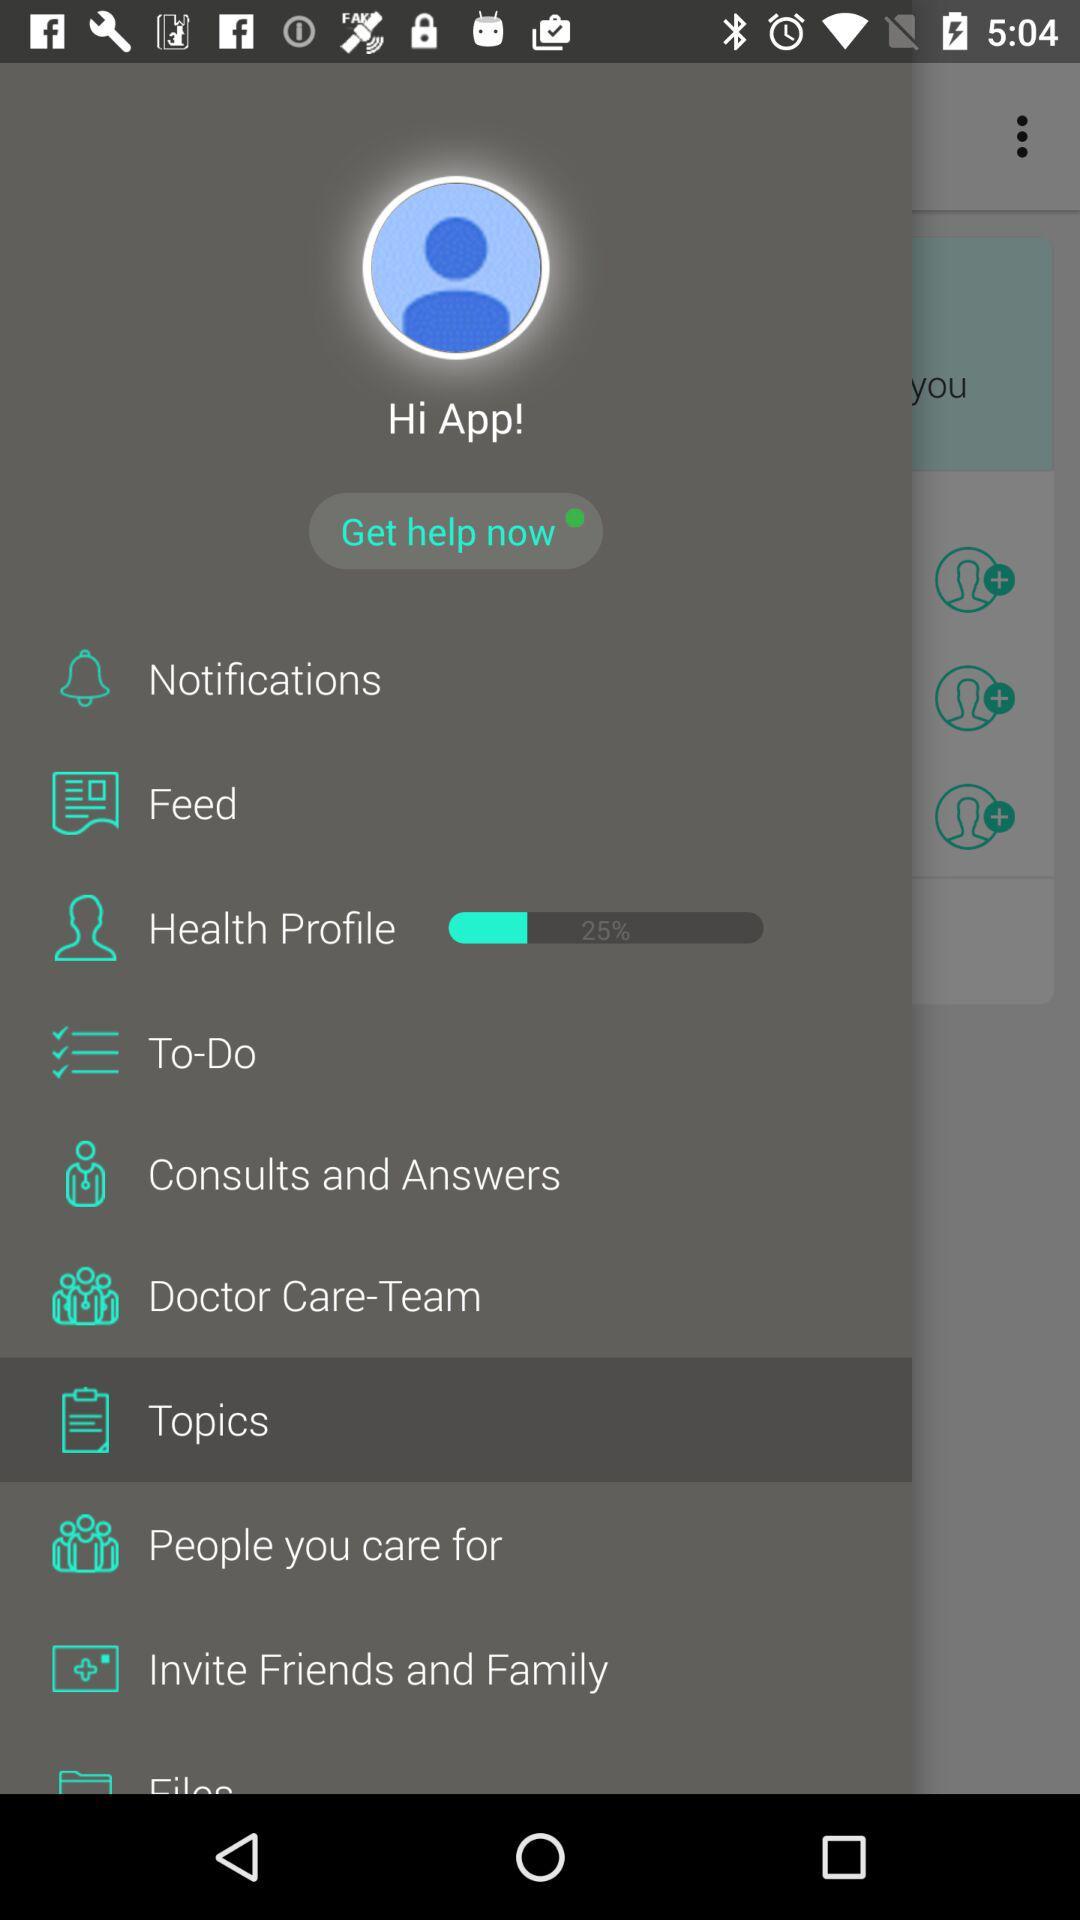What is the profile name? The profile name is App. 